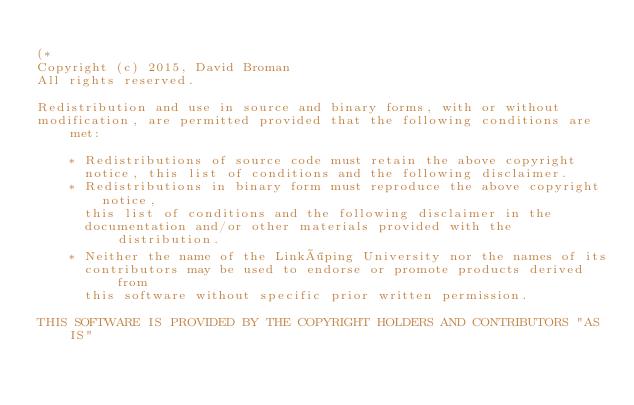Convert code to text. <code><loc_0><loc_0><loc_500><loc_500><_OCaml_>
(*
Copyright (c) 2015, David Broman
All rights reserved.

Redistribution and use in source and binary forms, with or without
modification, are permitted provided that the following conditions are met:

    * Redistributions of source code must retain the above copyright
      notice, this list of conditions and the following disclaimer.
    * Redistributions in binary form must reproduce the above copyright notice,
      this list of conditions and the following disclaimer in the
      documentation and/or other materials provided with the distribution.
    * Neither the name of the Linköping University nor the names of its
      contributors may be used to endorse or promote products derived from
      this software without specific prior written permission.

THIS SOFTWARE IS PROVIDED BY THE COPYRIGHT HOLDERS AND CONTRIBUTORS "AS IS"</code> 